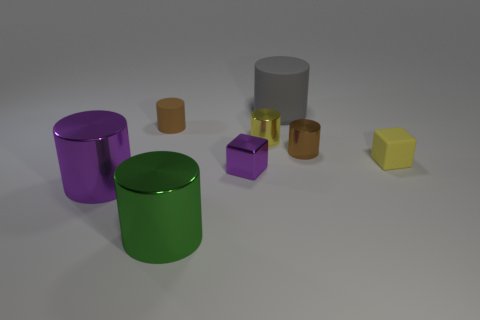There is a tiny object that is the same color as the tiny rubber cylinder; what is its material?
Your response must be concise. Metal. What number of large cylinders are the same color as the tiny metal cube?
Provide a short and direct response. 1. There is a block to the right of the small brown thing on the right side of the tiny brown thing to the left of the big matte object; what is its color?
Provide a succinct answer. Yellow. Are there any shiny objects left of the yellow metallic thing?
Provide a short and direct response. Yes. There is a shiny cylinder that is the same color as the tiny metal block; what is its size?
Provide a succinct answer. Large. Is there a yellow thing that has the same material as the yellow cylinder?
Offer a very short reply. No. What is the color of the matte block?
Ensure brevity in your answer.  Yellow. Is the shape of the large thing behind the tiny yellow metal cylinder the same as  the large purple object?
Your answer should be compact. Yes. There is a yellow thing behind the cube that is to the right of the large thing right of the big green metallic object; what is its shape?
Provide a succinct answer. Cylinder. There is a tiny cube that is on the left side of the small yellow rubber thing; what material is it?
Your answer should be compact. Metal. 